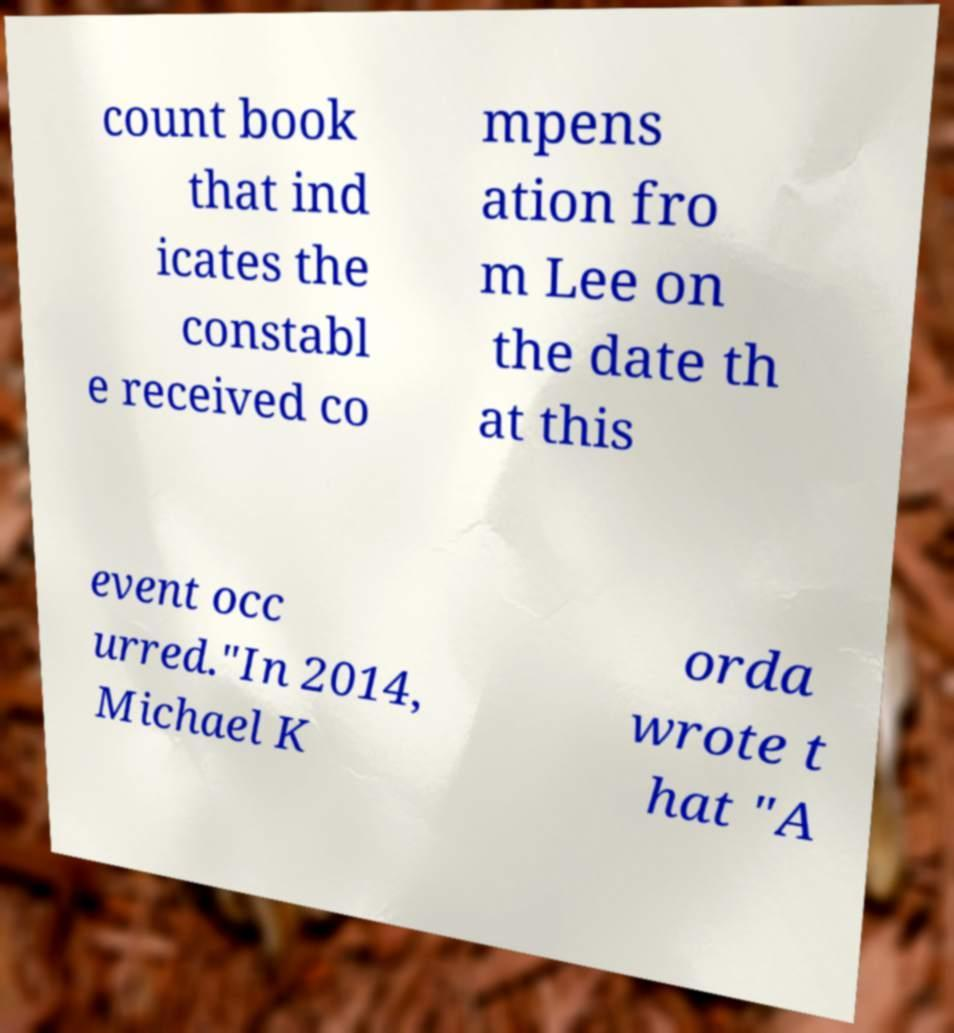Could you extract and type out the text from this image? count book that ind icates the constabl e received co mpens ation fro m Lee on the date th at this event occ urred."In 2014, Michael K orda wrote t hat "A 